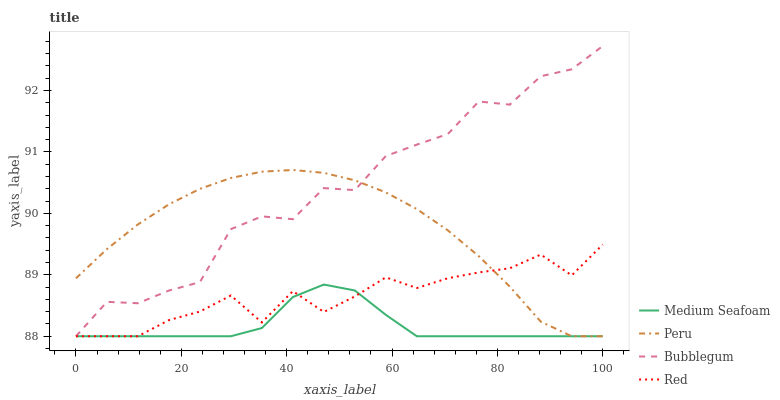Does Medium Seafoam have the minimum area under the curve?
Answer yes or no. Yes. Does Bubblegum have the maximum area under the curve?
Answer yes or no. Yes. Does Bubblegum have the minimum area under the curve?
Answer yes or no. No. Does Medium Seafoam have the maximum area under the curve?
Answer yes or no. No. Is Peru the smoothest?
Answer yes or no. Yes. Is Bubblegum the roughest?
Answer yes or no. Yes. Is Medium Seafoam the smoothest?
Answer yes or no. No. Is Medium Seafoam the roughest?
Answer yes or no. No. Does Red have the lowest value?
Answer yes or no. Yes. Does Bubblegum have the highest value?
Answer yes or no. Yes. Does Medium Seafoam have the highest value?
Answer yes or no. No. Does Red intersect Medium Seafoam?
Answer yes or no. Yes. Is Red less than Medium Seafoam?
Answer yes or no. No. Is Red greater than Medium Seafoam?
Answer yes or no. No. 